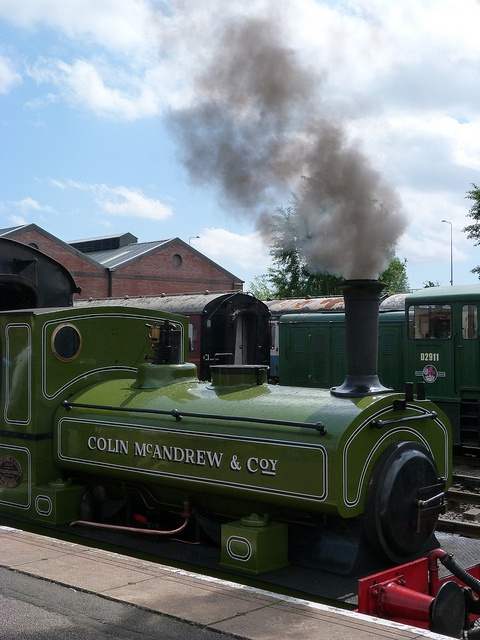Describe the objects in this image and their specific colors. I can see train in lavender, black, gray, darkgray, and darkgreen tones and train in lavender, black, gray, purple, and lightblue tones in this image. 